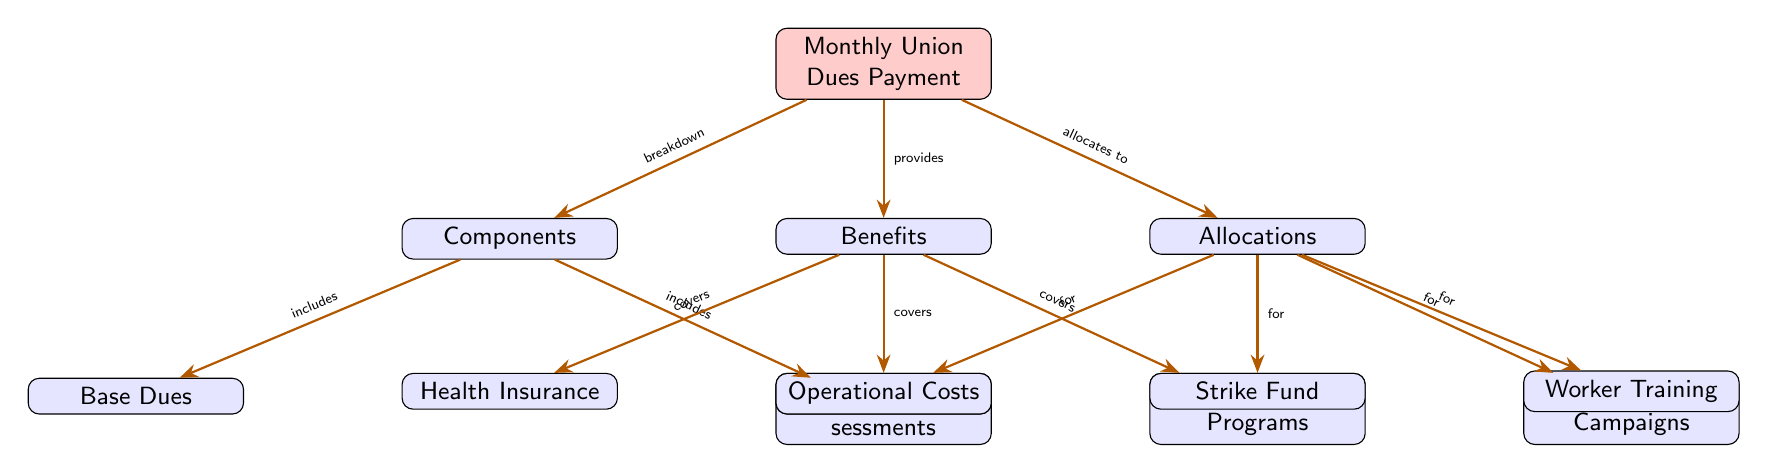What are the two main components of the monthly union dues payment? The diagram shows two main branches under the "Components" node: "Base Dues" and "Special Assessments". These are labeled directly in their respective nodes.
Answer: Base Dues, Special Assessments How many types of benefits are provided by the monthly union dues payment? Looking at the "Benefits" node, there are three branches stemming from it: "Health Insurance", "Legal Support", and "Educational Programs". Therefore, the number of benefit types corresponds directly to the number of branches.
Answer: 3 What does the monthly union dues payment allocate funds for? The "Allocations" node lists four branches: "Operational Costs", "Strike Fund", "Advocacy and Campaigns", and "Worker Training". These branches represent the intended allocations from the dues.
Answer: Operational Costs, Strike Fund, Advocacy and Campaigns, Worker Training Which benefit covers legal matters? In the "Benefits" section, there's a direct mention of the node labeled "Legal Support" under that category, which indicates that it is the benefit specifically covering legal matters.
Answer: Legal Support Which allocation is explicitly linked to the strike situation? Within the "Allocations" node, the "Strike Fund" is specifically mentioned, indicating it is the allocation intended for strike situations, as noted by its position and label in the diagram.
Answer: Strike Fund How is the operational cost related to union dues? The diagram illustrates that the union dues payment allocates funds to "Operational Costs" through a direct connection indicated by the arrow pointing from the "Allocations" node to "Operational Costs". This shows a clear relationship of funding.
Answer: Allocates to Operational Costs What type of union dues component is special assessments? The node "Special Assessments" is positioned directly under the "Components" node, indicating it is one of the types of components making up the union dues payment.
Answer: Component What is the relationship between components and benefits? The relationship is shown through the arrows from the "Monthly Union Dues Payment" node, one leading to "Components" and another leading to "Benefits". This indicates that the dues payment consists of components that ultimately provide various benefits.
Answer: Components lead to Benefits 